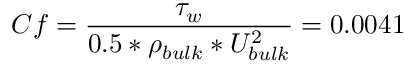<formula> <loc_0><loc_0><loc_500><loc_500>C f = \frac { \tau _ { w } } { 0 . 5 * \rho _ { b u l k } * U _ { b u l k } ^ { 2 } } = 0 . 0 0 4 1</formula> 